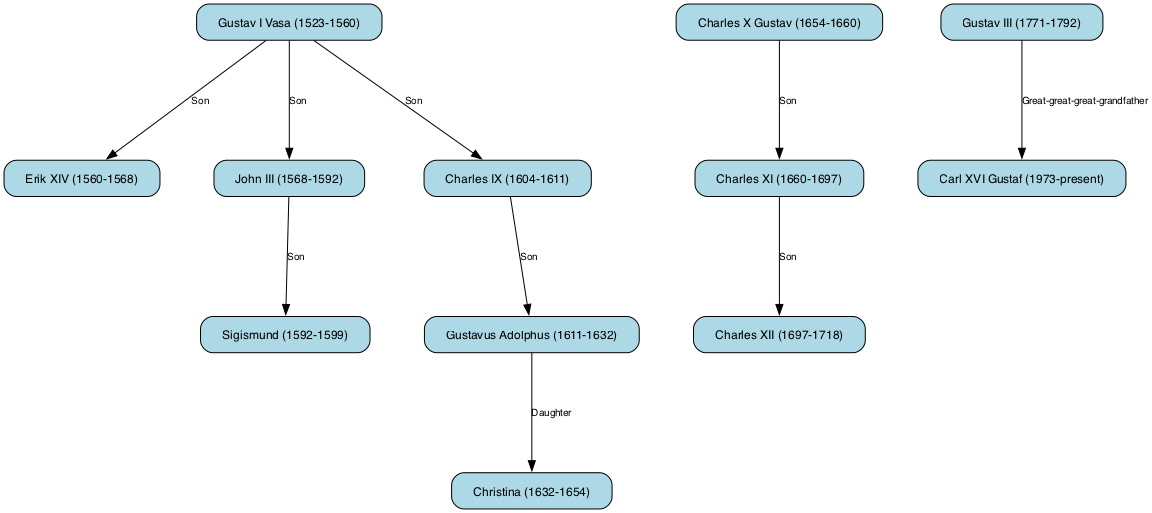What is the total number of nodes in the diagram? The diagram consists of 12 nodes representing various Swedish monarchs. To find the total, we count each distinct monarch listed in the nodes section.
Answer: 12 Who is the immediate successor of Gustav I Vasa? According to the diagram's directed edges, the direct connectivity from 'Gustav I Vasa' leads to 'Erik XIV', indicating that he is the immediate successor.
Answer: Erik XIV Which monarch is connected as a daughter to Gustavus Adolphus? The diagram shows that 'Christina I' is marked as a daughter of 'Gustavus Adolphus', which can be determined by inspecting the edge connecting these two nodes.
Answer: Christina How many sons did Gustav I Vasa have as depicted in the graph? By examining the edges, Gustav I Vasa has three connections labeled 'Son' leading to 'Erik XIV', 'John III', and 'Charles IX', indicating he had three sons.
Answer: 3 What is the relationship between Charles XI and Charles XII? The directed edge connecting 'Charles XI' to 'Charles XII' is labeled 'Son', signifying that Charles XII is the son of Charles XI.
Answer: Son Which monarch has the longest reign according to the graph? Reviewing the time frames of the monarchs, Charles XI reigned from 1660 to 1697, which totals 37 years, thus making him the monarch with the longest reign depicted in the graph.
Answer: Charles XI Who is the great-great-great-grandfather of Carl XVI Gustaf? The diagram indicates a directed edge from 'Gustav III' to 'Carl XVI Gustaf', labeled 'Great-great-great-grandfather', showing that Gustav III holds this ancestral title.
Answer: Gustav III Which monarch succeeded Christina I? Based on the directed edges in the graph, 'Charles X Gustav' directly follows 'Christina I', indicating he is her successor.
Answer: Charles X Gustav Which monarch ruled immediately before Carl XVI Gustaf? There are no direct predecessors listed for Carl XVI Gustaf in the diagram. However, looking at the edges, the last noted reign that connects in a notable ancestral line after him is from 'Gustav III', implying a significant time pathway.
Answer: Gustav III 